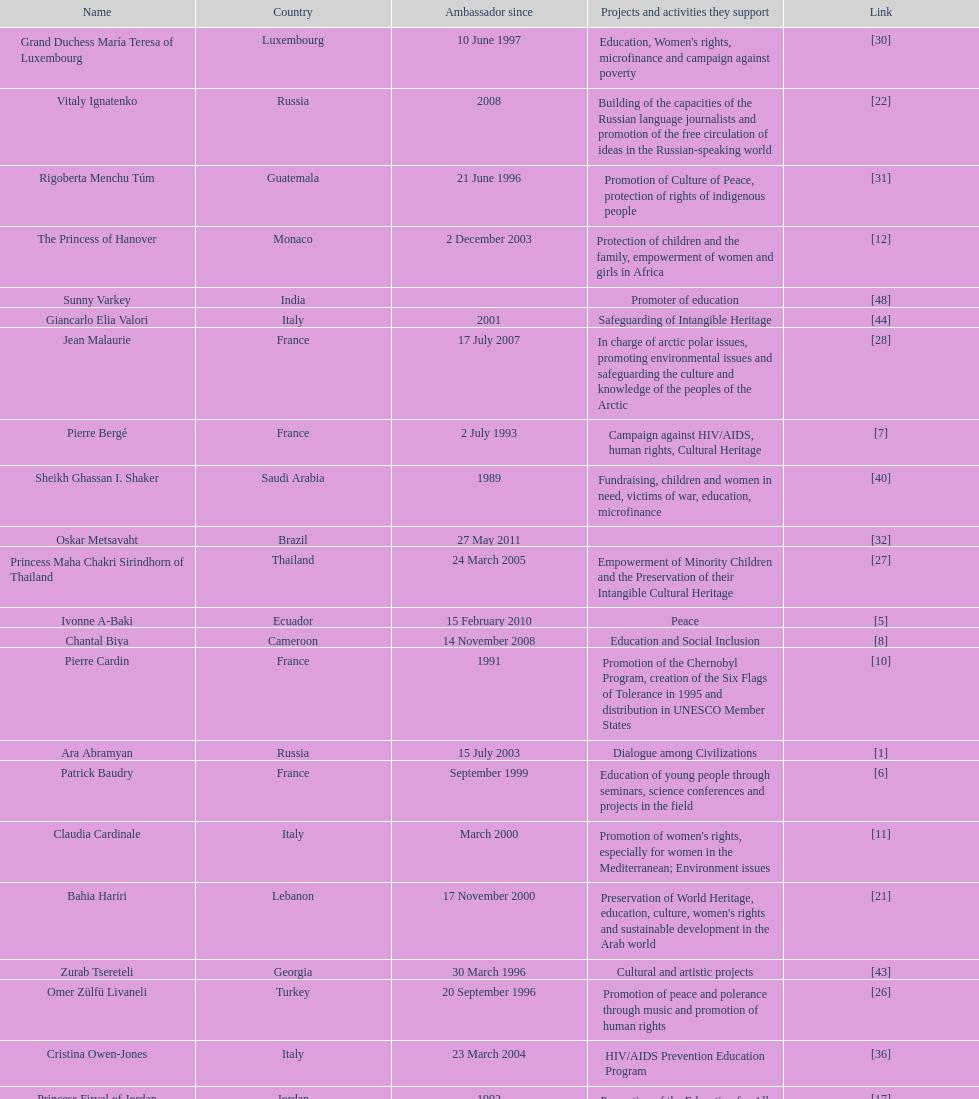Would you mind parsing the complete table? {'header': ['Name', 'Country', 'Ambassador since', 'Projects and activities they support', 'Link'], 'rows': [['Grand Duchess María Teresa of Luxembourg', 'Luxembourg', '10 June 1997', "Education, Women's rights, microfinance and campaign against poverty", '[30]'], ['Vitaly Ignatenko', 'Russia', '2008', 'Building of the capacities of the Russian language journalists and promotion of the free circulation of ideas in the Russian-speaking world', '[22]'], ['Rigoberta Menchu Túm', 'Guatemala', '21 June 1996', 'Promotion of Culture of Peace, protection of rights of indigenous people', '[31]'], ['The Princess of Hanover', 'Monaco', '2 December 2003', 'Protection of children and the family, empowerment of women and girls in Africa', '[12]'], ['Sunny Varkey', 'India', '', 'Promoter of education', '[48]'], ['Giancarlo Elia Valori', 'Italy', '2001', 'Safeguarding of Intangible Heritage', '[44]'], ['Jean Malaurie', 'France', '17 July 2007', 'In charge of arctic polar issues, promoting environmental issues and safeguarding the culture and knowledge of the peoples of the Arctic', '[28]'], ['Pierre Bergé', 'France', '2 July 1993', 'Campaign against HIV/AIDS, human rights, Cultural Heritage', '[7]'], ['Sheikh Ghassan I. Shaker', 'Saudi Arabia', '1989', 'Fundraising, children and women in need, victims of war, education, microfinance', '[40]'], ['Oskar Metsavaht', 'Brazil', '27 May 2011', '', '[32]'], ['Princess Maha Chakri Sirindhorn of Thailand', 'Thailand', '24 March 2005', 'Empowerment of Minority Children and the Preservation of their Intangible Cultural Heritage', '[27]'], ['Ivonne A-Baki', 'Ecuador', '15 February 2010', 'Peace', '[5]'], ['Chantal Biya', 'Cameroon', '14 November 2008', 'Education and Social Inclusion', '[8]'], ['Pierre Cardin', 'France', '1991', 'Promotion of the Chernobyl Program, creation of the Six Flags of Tolerance in 1995 and distribution in UNESCO Member States', '[10]'], ['Ara Abramyan', 'Russia', '15 July 2003', 'Dialogue among Civilizations', '[1]'], ['Patrick Baudry', 'France', 'September 1999', 'Education of young people through seminars, science conferences and projects in the field', '[6]'], ['Claudia Cardinale', 'Italy', 'March 2000', "Promotion of women's rights, especially for women in the Mediterranean; Environment issues", '[11]'], ['Bahia Hariri', 'Lebanon', '17 November 2000', "Preservation of World Heritage, education, culture, women's rights and sustainable development in the Arab world", '[21]'], ['Zurab Tsereteli', 'Georgia', '30 March 1996', 'Cultural and artistic projects', '[43]'], ['Omer Zülfü Livaneli', 'Turkey', '20 September 1996', 'Promotion of peace and polerance through music and promotion of human rights', '[26]'], ['Cristina Owen-Jones', 'Italy', '23 March 2004', 'HIV/AIDS Prevention Education Program', '[36]'], ['Princess Firyal of Jordan', 'Jordan', '1992', "Promotion of the Education for All initiative, humanitarian actions, World Heritage, women's rights, especially Arab women", '[17]'], ['Milú Villela', 'Brazil', '10 November 2004', 'Voluntary Action and Basic Education in Latin America', '[46]'], ['Cheick Modibo Diarra', 'Mali', '1998', 'Promotion of education, especially in sciences, sustainable development in Africa', '[14]'], ['Vik Muniz', 'Brazil', '27 May 2011', '', '[33]'], ['Jean Michel Jarre', 'France', '24 May 1993', 'Protection of the environment (water, fight against desertification, renewable energies), youth and tolerance, safeguarding of World Heritage', '[23]'], ['Keith Chatsauka-Coetzee', 'South Africa', '12 July 2012', '', '[29]'], ['Hayat Sindi', 'Saudi Arabia', '1 October 2012', 'Promotion of science education for Arab women', '[41]'], ['Marianna Vardinoyannis', 'Greece', '21 October 1999', 'Protection of childhood; promotion of cultural olympics; humanitarian relief for war victims', '[45]'], ['Forest Whitaker', 'United States', '', '', '[47]'], ['Mehriban Aliyeva', 'Azerbaijan', '9 September 2004', 'Promotion and safeguarding of intangible cultural heritage, especially oral traditions and expressions', '[3]'], ['Ivry Gitlis', 'Israel', '1990', 'Support of education and Culture of Peace and Tolerance', '[18]'], ['Nizan Guanaes', 'Brazil', '27 May 2011', '', '[19]'], ['Laura Welch Bush', 'United States', '13 February 2003', 'UNESCO Honorary Ambassador for the Decade of Literacy in the context of the United Nations Literacy Decade (2003–2012)', '[49]'], ['Esther Coopersmith', 'United States', '', '', '[13]'], ['Ute-Henriette Ohoven', 'Germany', '1992', 'UNESCO Special Ambassador for Education of Children in Need', '[35]'], ['Madanjeet Singh', 'India', '16 November 2000', 'Founder of the South Asia Foundation, which promotes regional cooperation through education and sustainable development', '[42]'], ['Miguel Angel Estrella', 'Argentina', '26 October 1989', 'Promotion of Culture of Peace and tolerance through music', '[15]'], ['Marc Ladreit de Lacharrière', 'France', '27 August 2009', '', '[24]'], ['Susana Rinaldi', 'Argentina', '28 April 1992', 'Street children, Culture of Peace', '[38]'], ['Christine Hakim', 'Indonesia', '11 March 2008', 'Teacher education in South East Asia', '[20]'], ['Yazid Sabeg', 'Algeria', '16 February 2010', '', '[39]'], ['Montserrat Caballé', 'Spain', '22 April 1994', 'Fundraising for children in distress and victims of war', '[9]'], ['Kim Phuc Phan Thi', 'Vietnam', '10 November 1994', 'Protection and education for children, orphans and innocent victims of war', '[37]'], ['Alicia Alonso', 'Cuba', '7 June 2002', 'Promotion of ballet dancing (Programme of Intangible Heritage)', '[4]'], ['Princess Lalla Meryem of Morocco', 'Morocco', 'July 2001', "Protection of childhood and women's rights", '[25]'], ['Kitín Muñoz', 'Spain', '22 April 1997', 'Protection and promotion of indigenous cultures and their environment', '[34]'], ['Vigdís Finnbogadóttir', 'Iceland', '1998', "Promotion of linguistic diversity, women's rights, education", '[16]'], ['Valdas Adamkus', 'Lithuania', '29 September 2003', 'Construction of Knowledge Societies', '[2]']]} Which unesco goodwill ambassador is most known for the promotion of the chernobyl program? Pierre Cardin. 